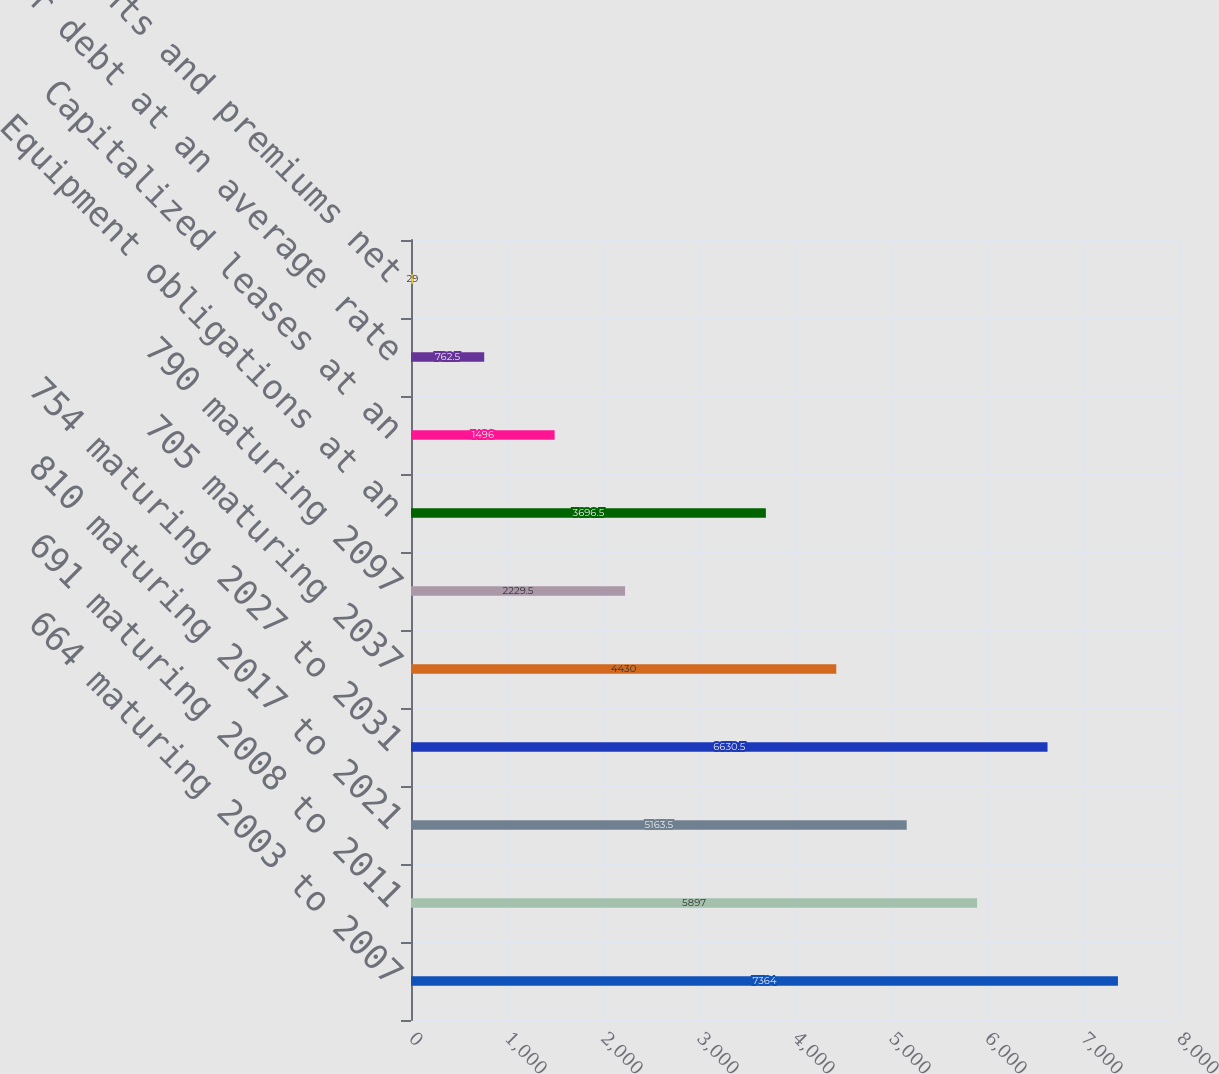<chart> <loc_0><loc_0><loc_500><loc_500><bar_chart><fcel>664 maturing 2003 to 2007<fcel>691 maturing 2008 to 2011<fcel>810 maturing 2017 to 2021<fcel>754 maturing 2027 to 2031<fcel>705 maturing 2037<fcel>790 maturing 2097<fcel>Equipment obligations at an<fcel>Capitalized leases at an<fcel>Other debt at an average rate<fcel>Discounts and premiums net<nl><fcel>7364<fcel>5897<fcel>5163.5<fcel>6630.5<fcel>4430<fcel>2229.5<fcel>3696.5<fcel>1496<fcel>762.5<fcel>29<nl></chart> 